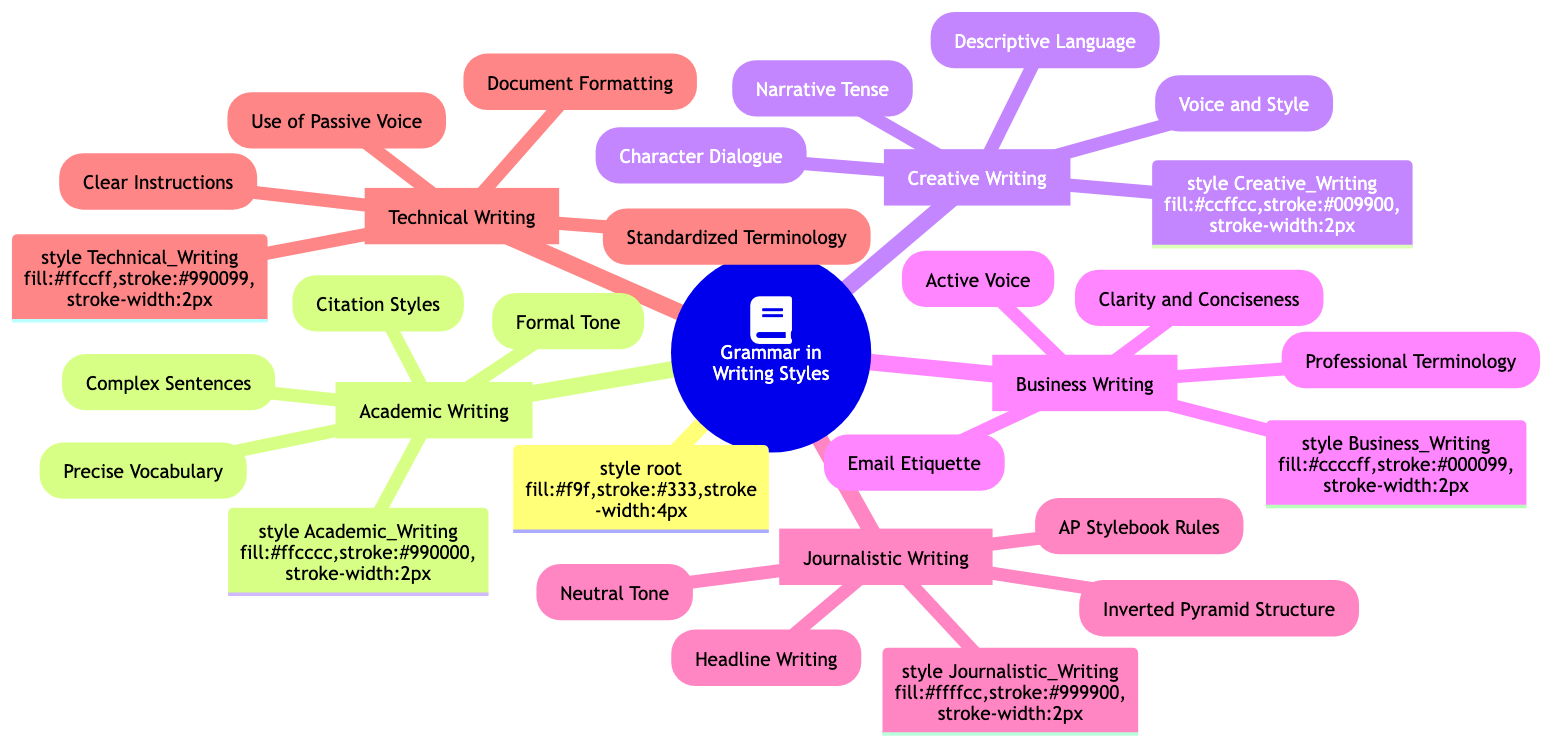What is the first section listed in the Mind Map? The Mind Map starts with the root node titled "Application of Grammar in Different Writing Styles". The first category listed under this root is "Academic Writing".
Answer: Academic Writing How many writing styles are mentioned in the Mind Map? The Mind Map contains five distinct writing styles: Academic Writing, Creative Writing, Business Writing, Journalistic Writing, and Technical Writing. Thus, the total is five.
Answer: Five What type of tone is associated with Academic Writing? Within the Academic Writing section, "Formal Tone" is explicitly mentioned as a key characteristic of this writing style.
Answer: Formal Tone Which writing style includes "Inverted Pyramid Structure"? The "Inverted Pyramid Structure" is found in the Journalistic Writing section, indicating its relevance to that specific writing style.
Answer: Journalistic Writing What are the elements listed under Creative Writing? The elements listed under Creative Writing are "Character Dialogue," "Narrative Tense," "Descriptive Language," and "Voice and Style," making four components in total.
Answer: Character Dialogue, Narrative Tense, Descriptive Language, Voice and Style Which writing style emphasizes "Clarity and Conciseness"? The writing style that emphasizes "Clarity and Conciseness" is Business Writing, marking it as a crucial aspect of this style.
Answer: Business Writing What is a common characteristic of Technical Writing based on the Mind Map? A common characteristic highlighted in the Technical Writing section is "Clear Instructions," suggesting clarity in written communication is prioritized in this style.
Answer: Clear Instructions How many elements are there under Business Writing? There are four specific elements listed under Business Writing: "Clarity and Conciseness," "Active Voice," "Professional Terminology," and "Email Etiquette". Hence, the total is four.
Answer: Four What does "AP Stylebook Rules" refer to in the context of the Mind Map? "AP Stylebook Rules" refers to a guideline followed in Journalistic Writing, indicating its importance in providing a standardized approach to writing in this field.
Answer: Journalistic Writing 